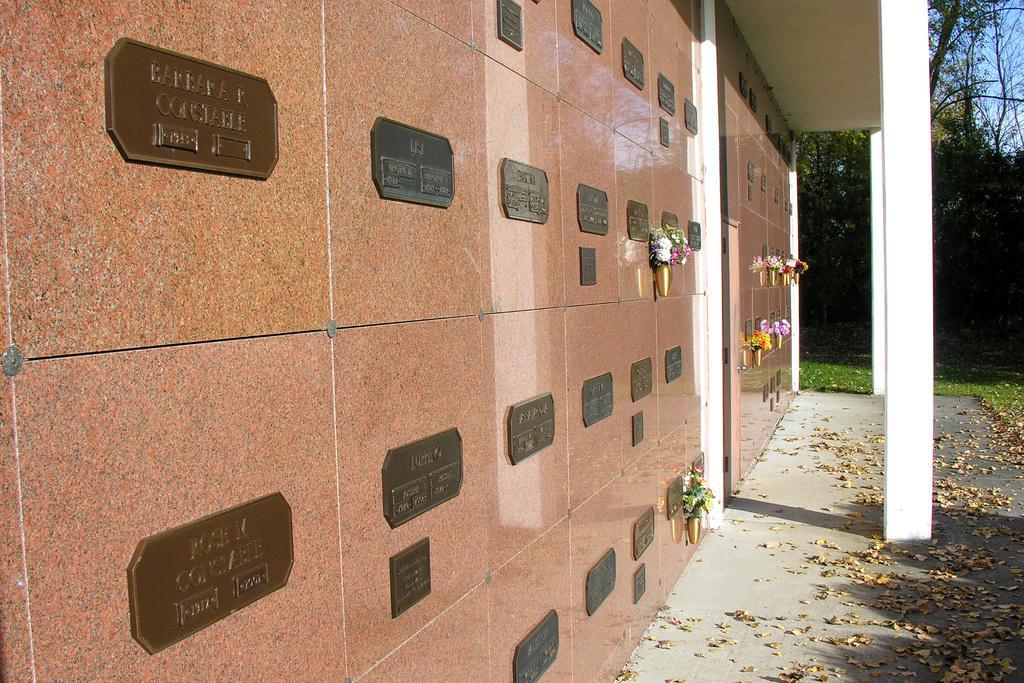Describe this image in one or two sentences. In this image I can see few flowers attached to the wall and the flowers are in multi color and I can also see few boards attached to the wall and the wall is in brown color. Background I can see few pillars in white color, trees in green color and the sky is in blue color. 